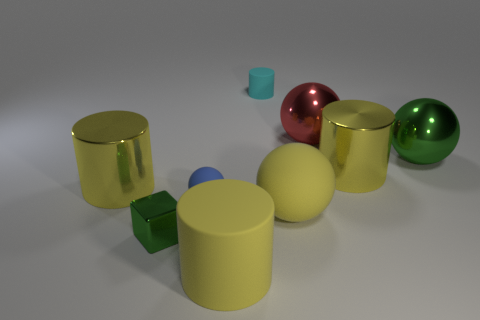How many yellow cylinders must be subtracted to get 1 yellow cylinders? 2 Add 1 big green metallic spheres. How many objects exist? 10 Subtract all tiny blue matte balls. How many balls are left? 3 Subtract all cubes. How many objects are left? 8 Subtract all blue cylinders. How many green balls are left? 1 Subtract all big brown metal blocks. Subtract all tiny green blocks. How many objects are left? 8 Add 1 green metal spheres. How many green metal spheres are left? 2 Add 5 brown matte cylinders. How many brown matte cylinders exist? 5 Subtract all blue spheres. How many spheres are left? 3 Subtract 0 cyan balls. How many objects are left? 9 